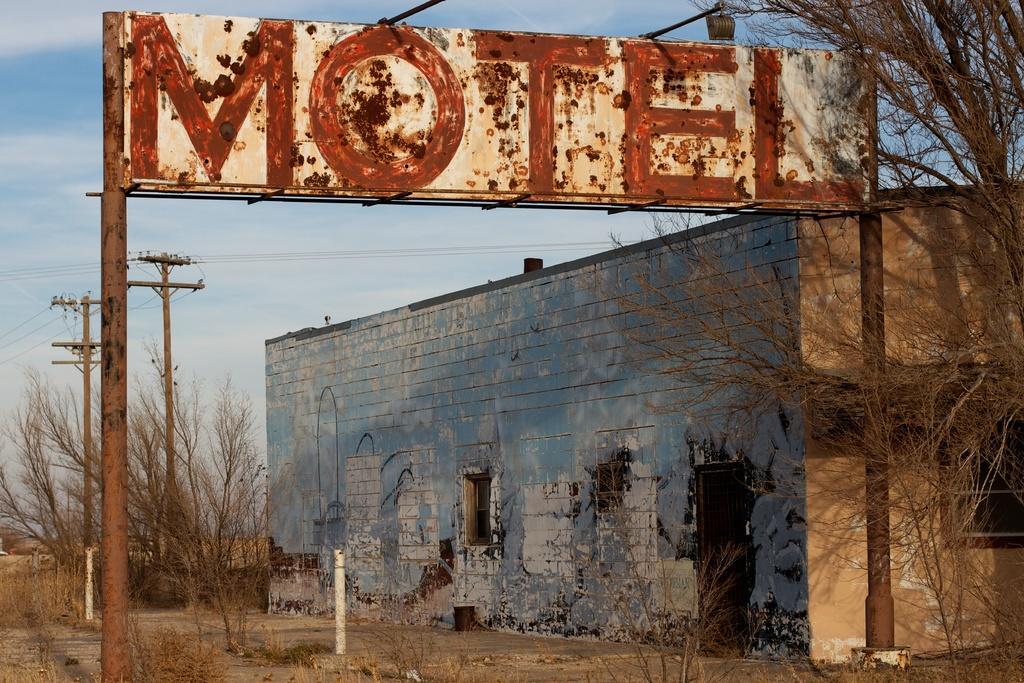Describe this image in one or two sentences. In the center of the image we can see house, windows, door, trees, poles, electric light poles. In the background of the image we can see board, poles, clouds are present in the sky, lights. At the bottom of the image there is a ground. 